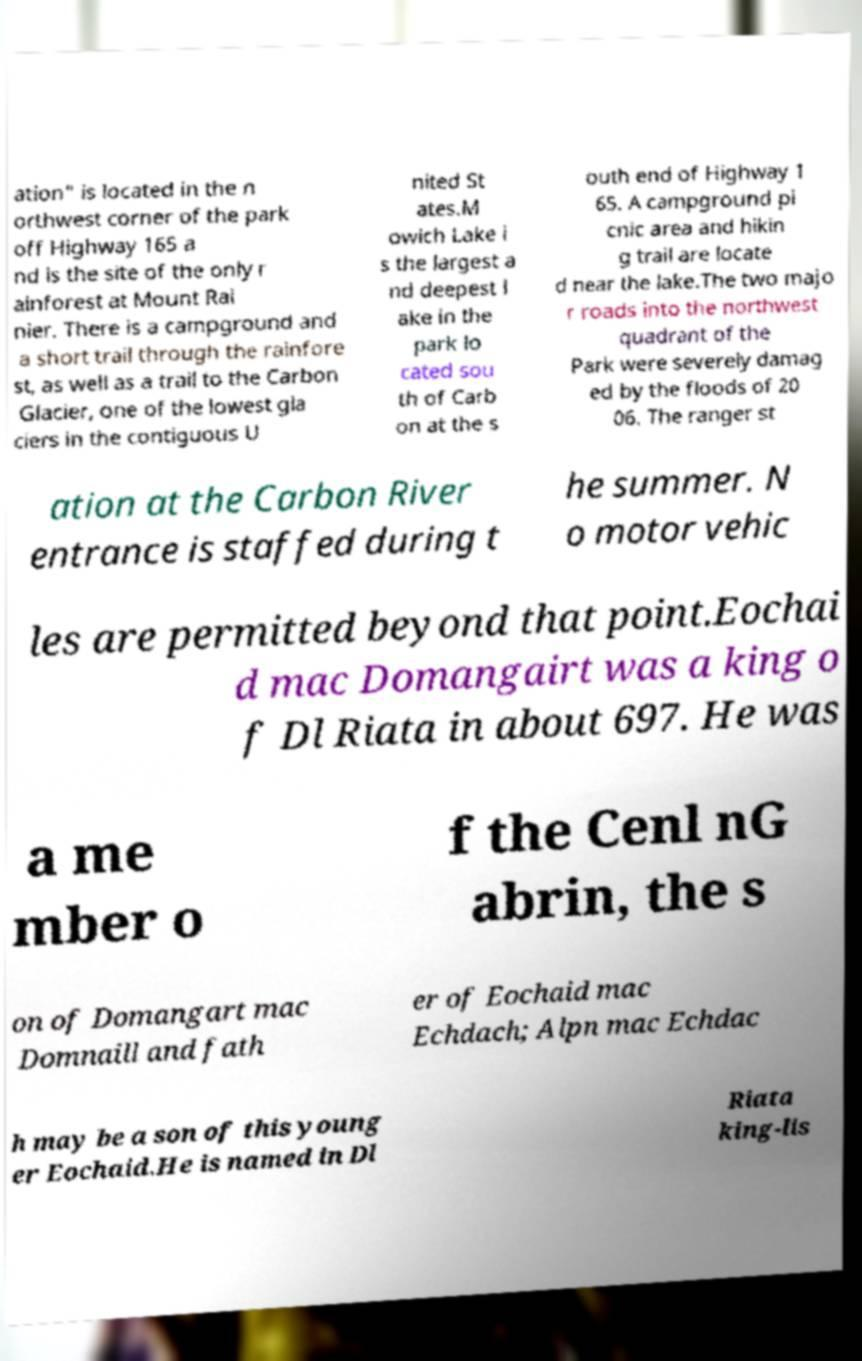What messages or text are displayed in this image? I need them in a readable, typed format. ation" is located in the n orthwest corner of the park off Highway 165 a nd is the site of the only r ainforest at Mount Rai nier. There is a campground and a short trail through the rainfore st, as well as a trail to the Carbon Glacier, one of the lowest gla ciers in the contiguous U nited St ates.M owich Lake i s the largest a nd deepest l ake in the park lo cated sou th of Carb on at the s outh end of Highway 1 65. A campground pi cnic area and hikin g trail are locate d near the lake.The two majo r roads into the northwest quadrant of the Park were severely damag ed by the floods of 20 06. The ranger st ation at the Carbon River entrance is staffed during t he summer. N o motor vehic les are permitted beyond that point.Eochai d mac Domangairt was a king o f Dl Riata in about 697. He was a me mber o f the Cenl nG abrin, the s on of Domangart mac Domnaill and fath er of Eochaid mac Echdach; Alpn mac Echdac h may be a son of this young er Eochaid.He is named in Dl Riata king-lis 